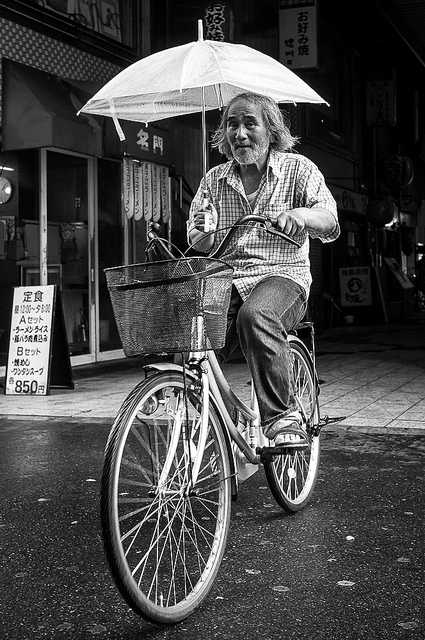Extract all visible text content from this image. A 850 